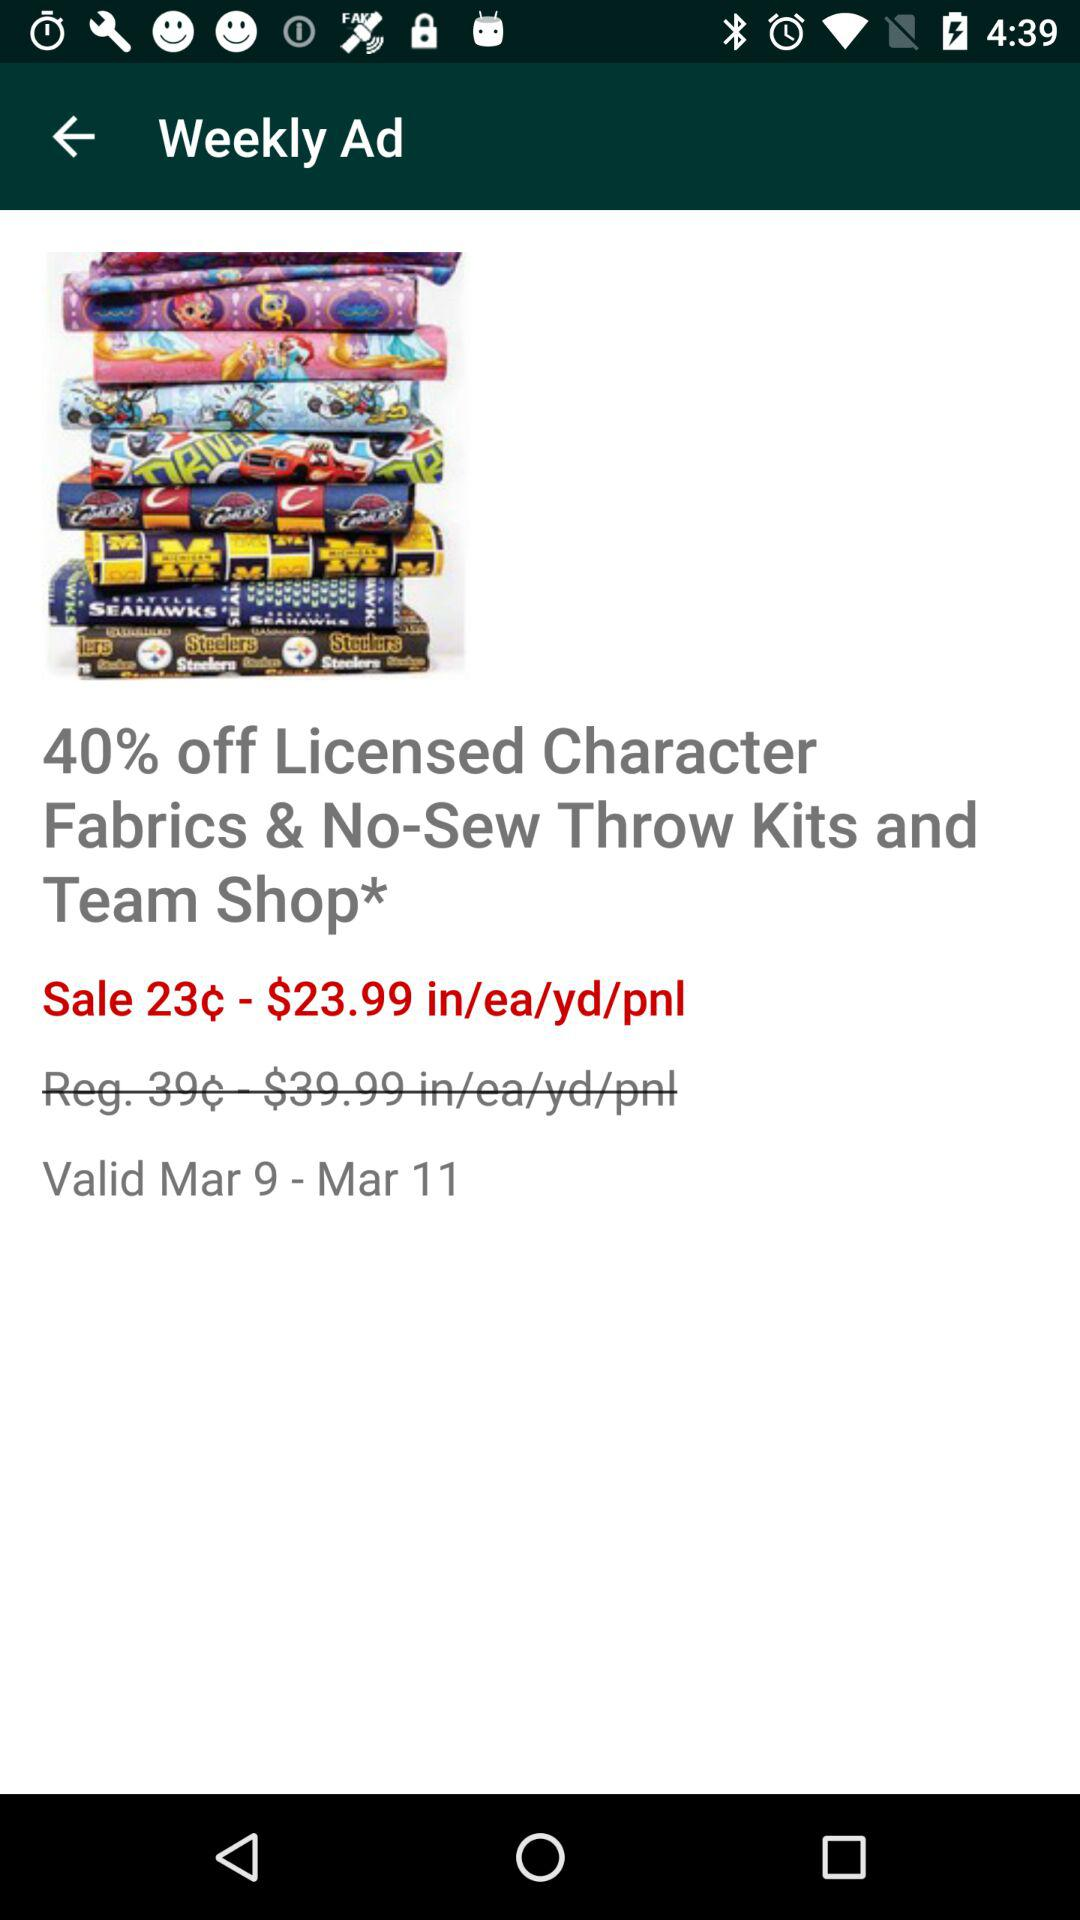How many days is the sale valid for?
Answer the question using a single word or phrase. 3 